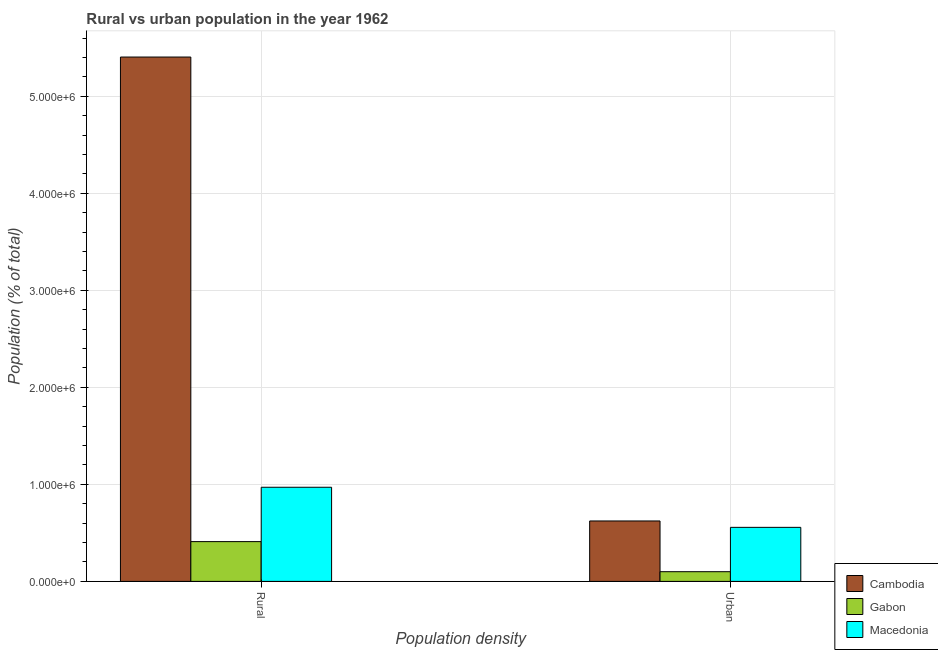How many different coloured bars are there?
Provide a succinct answer. 3. Are the number of bars per tick equal to the number of legend labels?
Offer a terse response. Yes. Are the number of bars on each tick of the X-axis equal?
Offer a terse response. Yes. How many bars are there on the 1st tick from the right?
Provide a short and direct response. 3. What is the label of the 1st group of bars from the left?
Provide a short and direct response. Rural. What is the urban population density in Cambodia?
Provide a short and direct response. 6.23e+05. Across all countries, what is the maximum rural population density?
Provide a succinct answer. 5.40e+06. Across all countries, what is the minimum rural population density?
Provide a short and direct response. 4.10e+05. In which country was the urban population density maximum?
Your answer should be very brief. Cambodia. In which country was the rural population density minimum?
Provide a succinct answer. Gabon. What is the total urban population density in the graph?
Provide a succinct answer. 1.28e+06. What is the difference between the rural population density in Gabon and that in Cambodia?
Keep it short and to the point. -4.99e+06. What is the difference between the rural population density in Macedonia and the urban population density in Gabon?
Your answer should be compact. 8.70e+05. What is the average urban population density per country?
Provide a short and direct response. 4.27e+05. What is the difference between the rural population density and urban population density in Cambodia?
Keep it short and to the point. 4.78e+06. In how many countries, is the rural population density greater than 5200000 %?
Your answer should be compact. 1. What is the ratio of the urban population density in Macedonia to that in Gabon?
Keep it short and to the point. 5.58. What does the 2nd bar from the left in Urban represents?
Keep it short and to the point. Gabon. What does the 3rd bar from the right in Rural represents?
Provide a succinct answer. Cambodia. Are all the bars in the graph horizontal?
Your answer should be compact. No. How many countries are there in the graph?
Your answer should be very brief. 3. Does the graph contain any zero values?
Your answer should be very brief. No. Does the graph contain grids?
Give a very brief answer. Yes. Where does the legend appear in the graph?
Provide a succinct answer. Bottom right. How many legend labels are there?
Keep it short and to the point. 3. What is the title of the graph?
Provide a short and direct response. Rural vs urban population in the year 1962. Does "Afghanistan" appear as one of the legend labels in the graph?
Keep it short and to the point. No. What is the label or title of the X-axis?
Provide a short and direct response. Population density. What is the label or title of the Y-axis?
Provide a succinct answer. Population (% of total). What is the Population (% of total) of Cambodia in Rural?
Provide a short and direct response. 5.40e+06. What is the Population (% of total) in Gabon in Rural?
Make the answer very short. 4.10e+05. What is the Population (% of total) of Macedonia in Rural?
Your answer should be very brief. 9.70e+05. What is the Population (% of total) in Cambodia in Urban?
Offer a very short reply. 6.23e+05. What is the Population (% of total) of Gabon in Urban?
Give a very brief answer. 9.99e+04. What is the Population (% of total) of Macedonia in Urban?
Your response must be concise. 5.57e+05. Across all Population density, what is the maximum Population (% of total) of Cambodia?
Give a very brief answer. 5.40e+06. Across all Population density, what is the maximum Population (% of total) in Gabon?
Provide a short and direct response. 4.10e+05. Across all Population density, what is the maximum Population (% of total) of Macedonia?
Keep it short and to the point. 9.70e+05. Across all Population density, what is the minimum Population (% of total) of Cambodia?
Give a very brief answer. 6.23e+05. Across all Population density, what is the minimum Population (% of total) of Gabon?
Keep it short and to the point. 9.99e+04. Across all Population density, what is the minimum Population (% of total) in Macedonia?
Give a very brief answer. 5.57e+05. What is the total Population (% of total) of Cambodia in the graph?
Offer a terse response. 6.03e+06. What is the total Population (% of total) of Gabon in the graph?
Ensure brevity in your answer.  5.10e+05. What is the total Population (% of total) of Macedonia in the graph?
Offer a very short reply. 1.53e+06. What is the difference between the Population (% of total) of Cambodia in Rural and that in Urban?
Give a very brief answer. 4.78e+06. What is the difference between the Population (% of total) of Gabon in Rural and that in Urban?
Offer a terse response. 3.10e+05. What is the difference between the Population (% of total) of Macedonia in Rural and that in Urban?
Make the answer very short. 4.13e+05. What is the difference between the Population (% of total) in Cambodia in Rural and the Population (% of total) in Gabon in Urban?
Offer a terse response. 5.30e+06. What is the difference between the Population (% of total) in Cambodia in Rural and the Population (% of total) in Macedonia in Urban?
Make the answer very short. 4.85e+06. What is the difference between the Population (% of total) in Gabon in Rural and the Population (% of total) in Macedonia in Urban?
Make the answer very short. -1.47e+05. What is the average Population (% of total) of Cambodia per Population density?
Keep it short and to the point. 3.01e+06. What is the average Population (% of total) of Gabon per Population density?
Provide a short and direct response. 2.55e+05. What is the average Population (% of total) in Macedonia per Population density?
Ensure brevity in your answer.  7.64e+05. What is the difference between the Population (% of total) in Cambodia and Population (% of total) in Gabon in Rural?
Ensure brevity in your answer.  4.99e+06. What is the difference between the Population (% of total) of Cambodia and Population (% of total) of Macedonia in Rural?
Offer a very short reply. 4.43e+06. What is the difference between the Population (% of total) in Gabon and Population (% of total) in Macedonia in Rural?
Provide a succinct answer. -5.60e+05. What is the difference between the Population (% of total) in Cambodia and Population (% of total) in Gabon in Urban?
Your response must be concise. 5.23e+05. What is the difference between the Population (% of total) of Cambodia and Population (% of total) of Macedonia in Urban?
Provide a short and direct response. 6.58e+04. What is the difference between the Population (% of total) in Gabon and Population (% of total) in Macedonia in Urban?
Offer a very short reply. -4.57e+05. What is the ratio of the Population (% of total) of Cambodia in Rural to that in Urban?
Keep it short and to the point. 8.68. What is the ratio of the Population (% of total) of Gabon in Rural to that in Urban?
Provide a short and direct response. 4.1. What is the ratio of the Population (% of total) of Macedonia in Rural to that in Urban?
Give a very brief answer. 1.74. What is the difference between the highest and the second highest Population (% of total) in Cambodia?
Provide a short and direct response. 4.78e+06. What is the difference between the highest and the second highest Population (% of total) of Gabon?
Provide a short and direct response. 3.10e+05. What is the difference between the highest and the second highest Population (% of total) in Macedonia?
Offer a very short reply. 4.13e+05. What is the difference between the highest and the lowest Population (% of total) of Cambodia?
Provide a short and direct response. 4.78e+06. What is the difference between the highest and the lowest Population (% of total) in Gabon?
Your response must be concise. 3.10e+05. What is the difference between the highest and the lowest Population (% of total) of Macedonia?
Your answer should be very brief. 4.13e+05. 